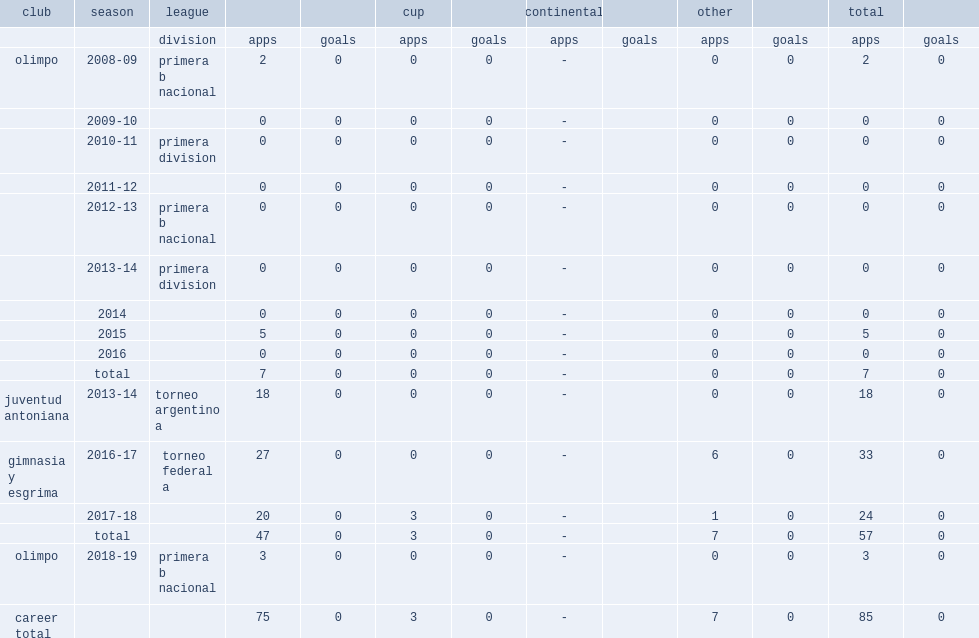Which league did viola play for olimpo during the 2008-09? Primera b nacional. 